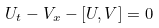Convert formula to latex. <formula><loc_0><loc_0><loc_500><loc_500>U _ { t } - V _ { x } - \left [ U , V \right ] = 0</formula> 